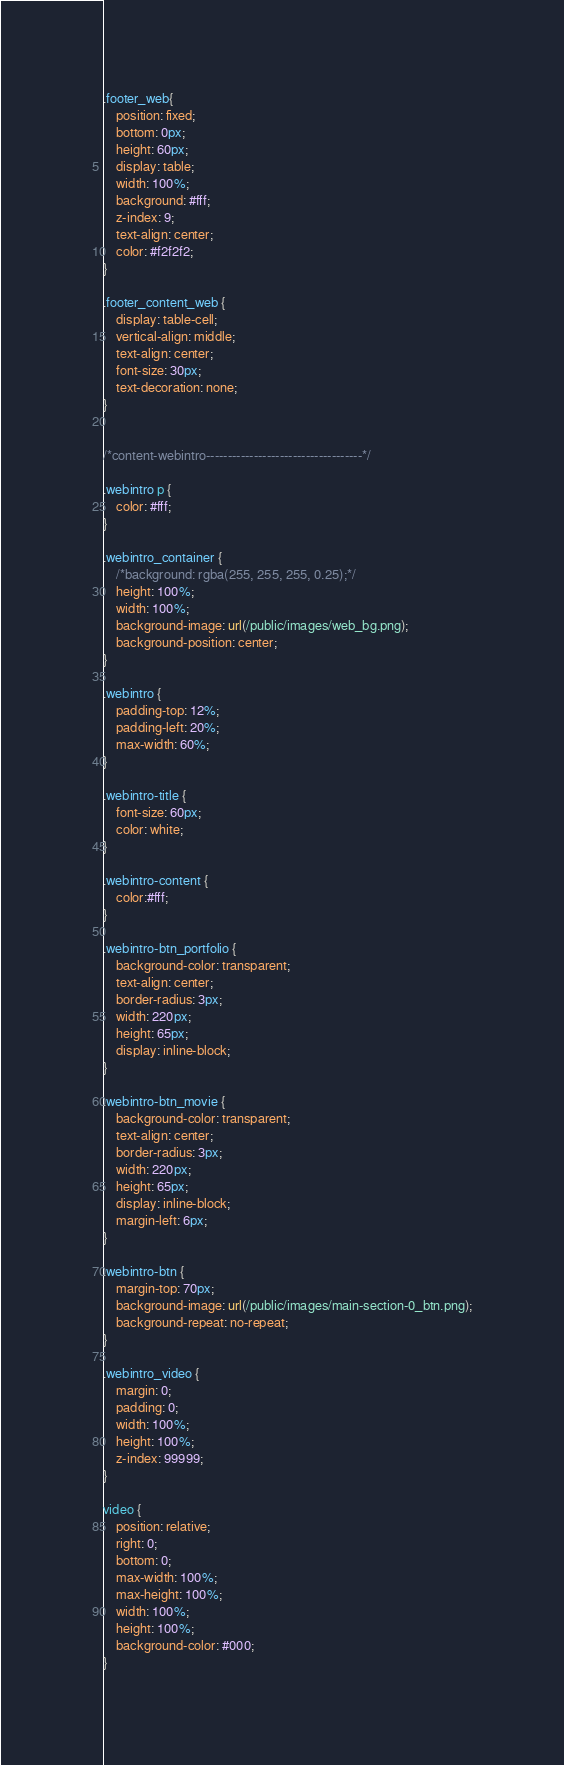Convert code to text. <code><loc_0><loc_0><loc_500><loc_500><_CSS_>.footer_web{
    position: fixed;
    bottom: 0px;
    height: 60px;
    display: table;
    width: 100%;
    background: #fff;
    z-index: 9;
    text-align: center;
    color: #f2f2f2;
}

.footer_content_web {
    display: table-cell;
    vertical-align: middle;
    text-align: center;
    font-size: 30px;
    text-decoration: none;
}


/*content-webintro------------------------------------*/

.webintro p {
    color: #fff;
}

.webintro_container {
    /*background: rgba(255, 255, 255, 0.25);*/
    height: 100%;
    width: 100%;
    background-image: url(/public/images/web_bg.png);
    background-position: center;
}

.webintro {
    padding-top: 12%;
    padding-left: 20%;
    max-width: 60%;
}

.webintro-title {
    font-size: 60px;
    color: white;
}

.webintro-content {
    color:#fff;
}

.webintro-btn_portfolio {
    background-color: transparent;
    text-align: center;
    border-radius: 3px;
    width: 220px;
    height: 65px;
    display: inline-block;
}

.webintro-btn_movie {
    background-color: transparent;
    text-align: center;
    border-radius: 3px;
    width: 220px;
    height: 65px;
    display: inline-block;
    margin-left: 6px;
}

.webintro-btn {
    margin-top: 70px;
    background-image: url(/public/images/main-section-0_btn.png);
    background-repeat: no-repeat;
}

.webintro_video {
    margin: 0;
    padding: 0;
    width: 100%;
    height: 100%;
    z-index: 99999;
}

video {
    position: relative;
    right: 0;
    bottom: 0;
    max-width: 100%;
    max-height: 100%;
    width: 100%;
    height: 100%;
    background-color: #000;
}





</code> 